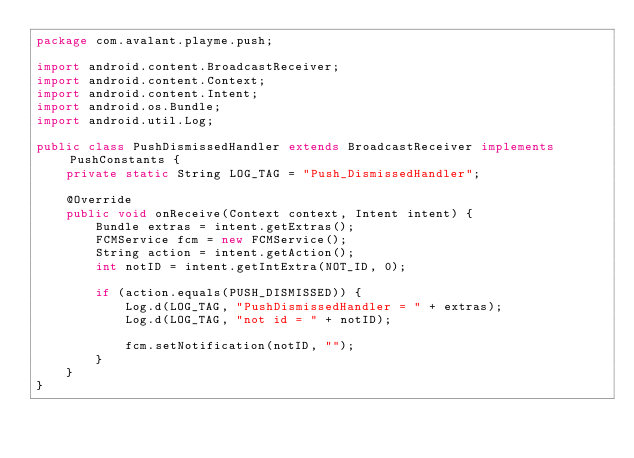<code> <loc_0><loc_0><loc_500><loc_500><_Java_>package com.avalant.playme.push;

import android.content.BroadcastReceiver;
import android.content.Context;
import android.content.Intent;
import android.os.Bundle;
import android.util.Log;

public class PushDismissedHandler extends BroadcastReceiver implements PushConstants {
    private static String LOG_TAG = "Push_DismissedHandler";

    @Override
    public void onReceive(Context context, Intent intent) {
        Bundle extras = intent.getExtras();
        FCMService fcm = new FCMService();
        String action = intent.getAction();
        int notID = intent.getIntExtra(NOT_ID, 0);

        if (action.equals(PUSH_DISMISSED)) {
            Log.d(LOG_TAG, "PushDismissedHandler = " + extras);
            Log.d(LOG_TAG, "not id = " + notID);

            fcm.setNotification(notID, "");
        }
    }
}
</code> 